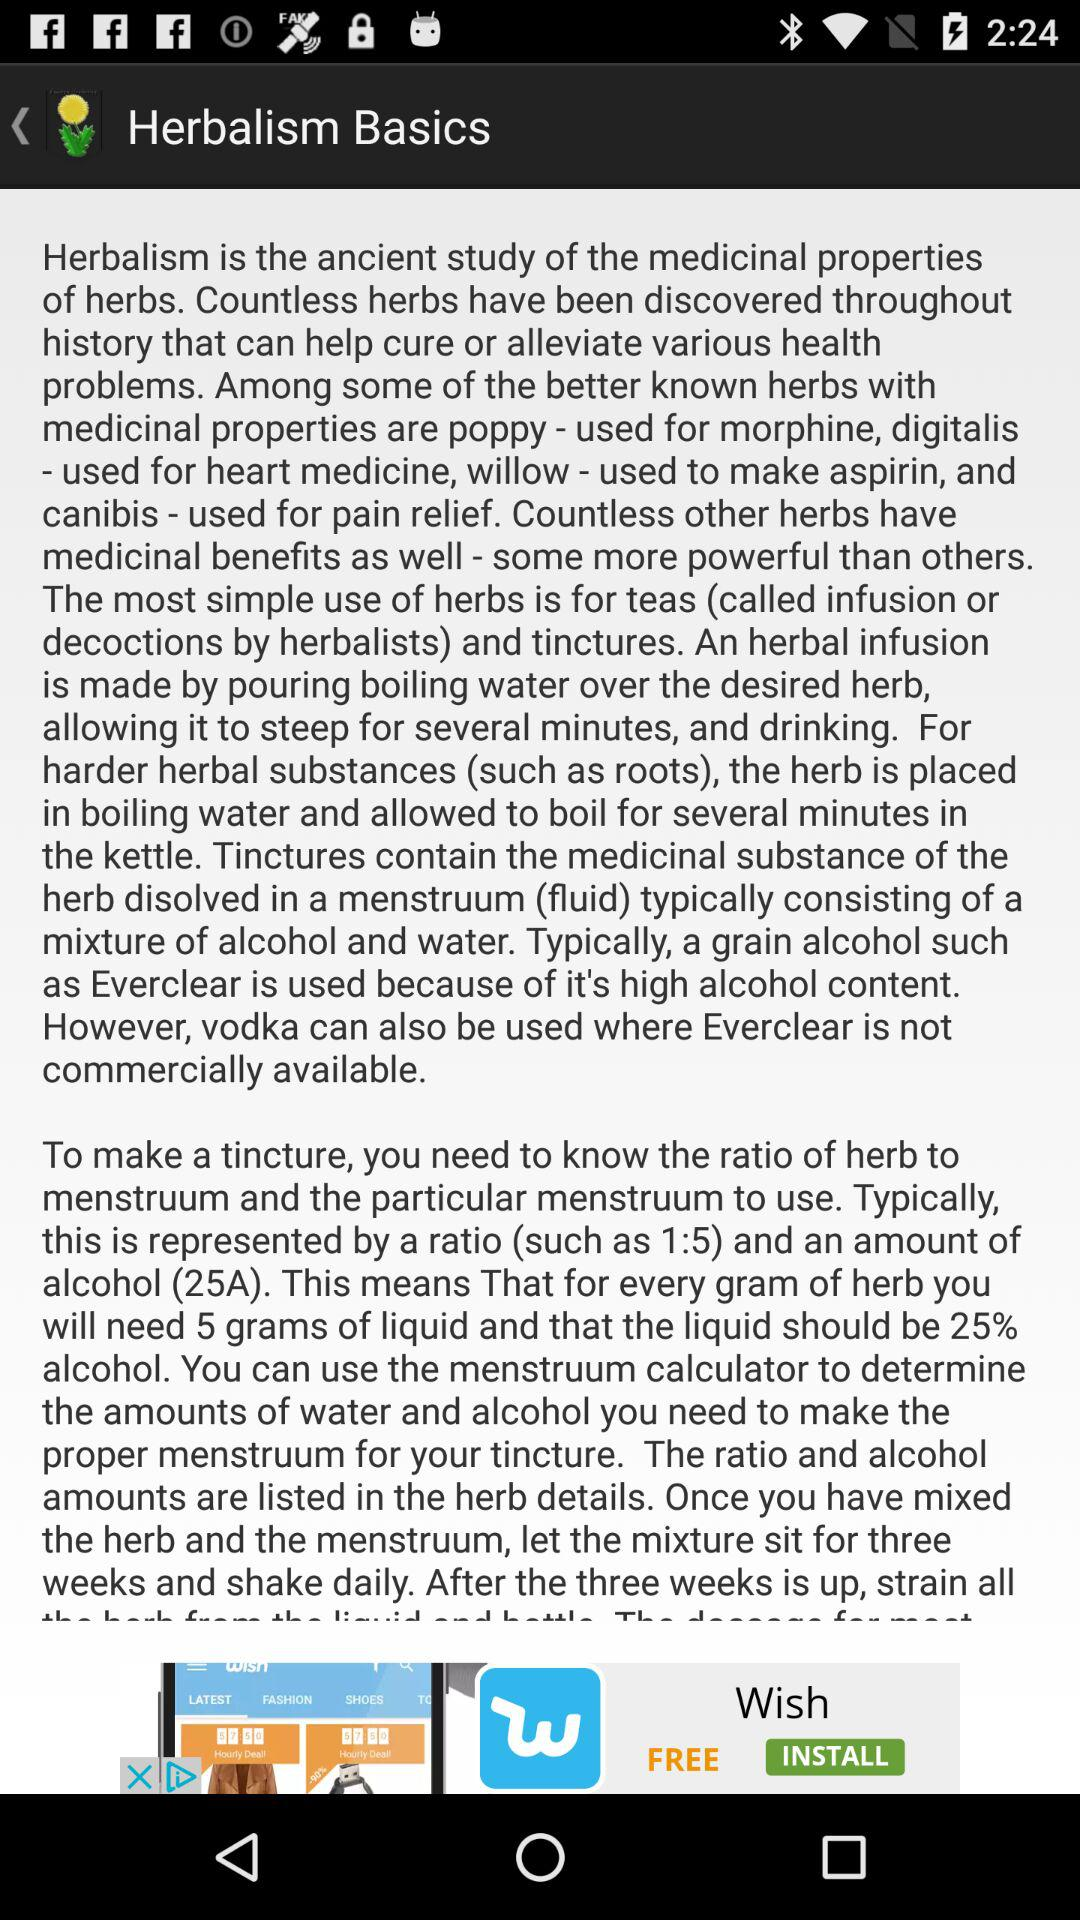How many ingredients are needed to make a tincture?
Answer the question using a single word or phrase. 2 